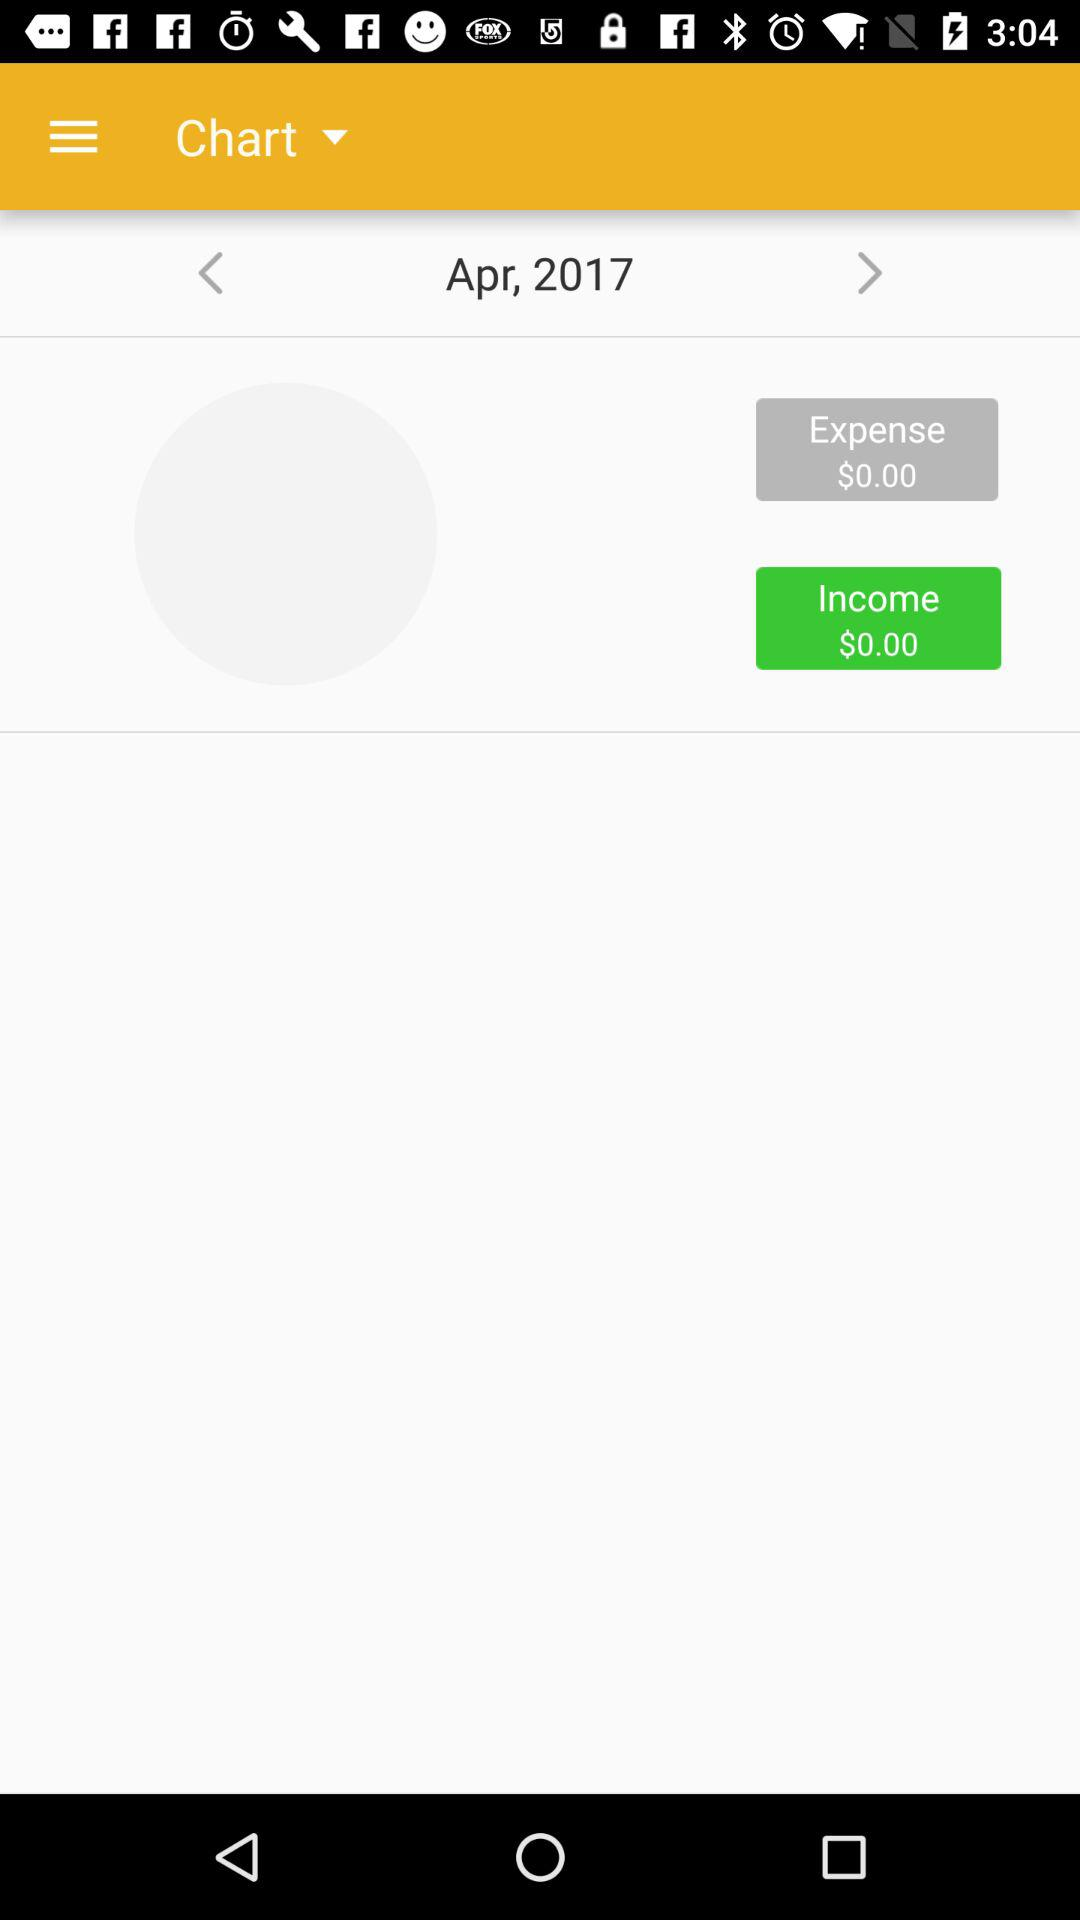What is the income? The income is $0.00. 